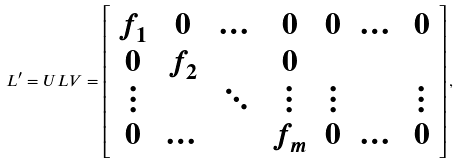<formula> <loc_0><loc_0><loc_500><loc_500>L ^ { \prime } = U L V = \left [ \begin{array} { c c c c c c c } f _ { 1 } & 0 & \dots & 0 & 0 & \dots & 0 \\ 0 & f _ { 2 } & \, & 0 & \, & \, & \, \\ \vdots & \, & \ddots & \vdots & \vdots & \, & \vdots \\ 0 & \dots & \, & f _ { m } & 0 & \dots & 0 \end{array} \right ] ,</formula> 